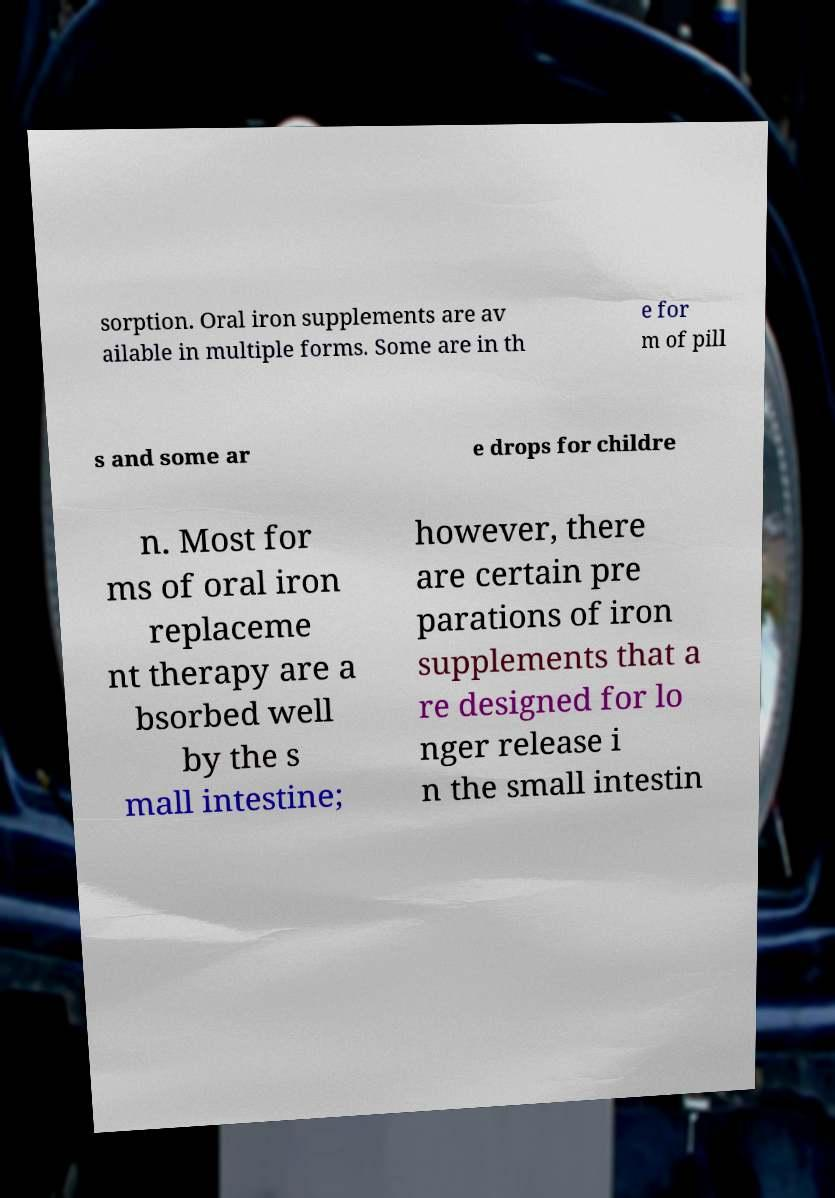Could you assist in decoding the text presented in this image and type it out clearly? sorption. Oral iron supplements are av ailable in multiple forms. Some are in th e for m of pill s and some ar e drops for childre n. Most for ms of oral iron replaceme nt therapy are a bsorbed well by the s mall intestine; however, there are certain pre parations of iron supplements that a re designed for lo nger release i n the small intestin 